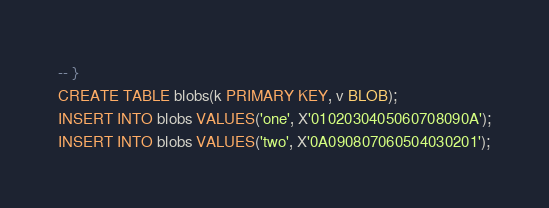Convert code to text. <code><loc_0><loc_0><loc_500><loc_500><_SQL_>-- }
CREATE TABLE blobs(k PRIMARY KEY, v BLOB);
INSERT INTO blobs VALUES('one', X'0102030405060708090A');
INSERT INTO blobs VALUES('two', X'0A090807060504030201');</code> 